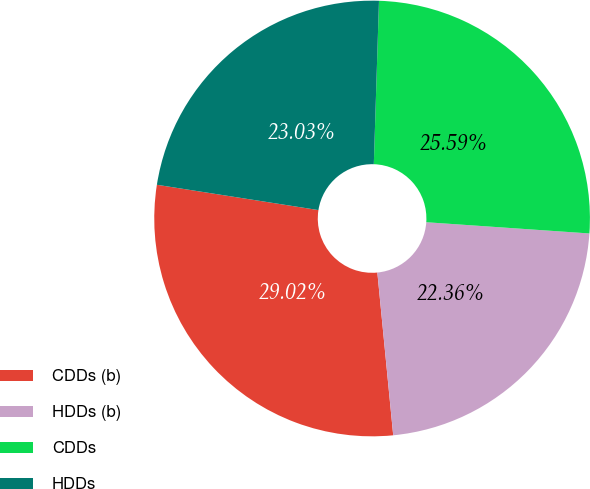Convert chart to OTSL. <chart><loc_0><loc_0><loc_500><loc_500><pie_chart><fcel>CDDs (b)<fcel>HDDs (b)<fcel>CDDs<fcel>HDDs<nl><fcel>29.02%<fcel>22.36%<fcel>25.59%<fcel>23.03%<nl></chart> 